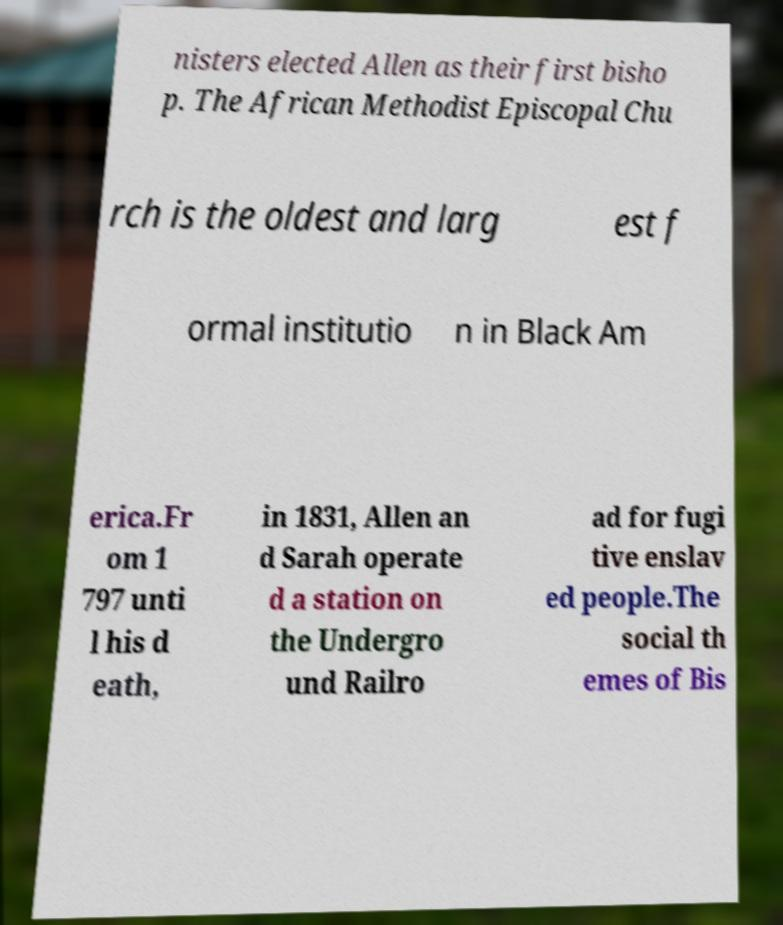Could you assist in decoding the text presented in this image and type it out clearly? nisters elected Allen as their first bisho p. The African Methodist Episcopal Chu rch is the oldest and larg est f ormal institutio n in Black Am erica.Fr om 1 797 unti l his d eath, in 1831, Allen an d Sarah operate d a station on the Undergro und Railro ad for fugi tive enslav ed people.The social th emes of Bis 